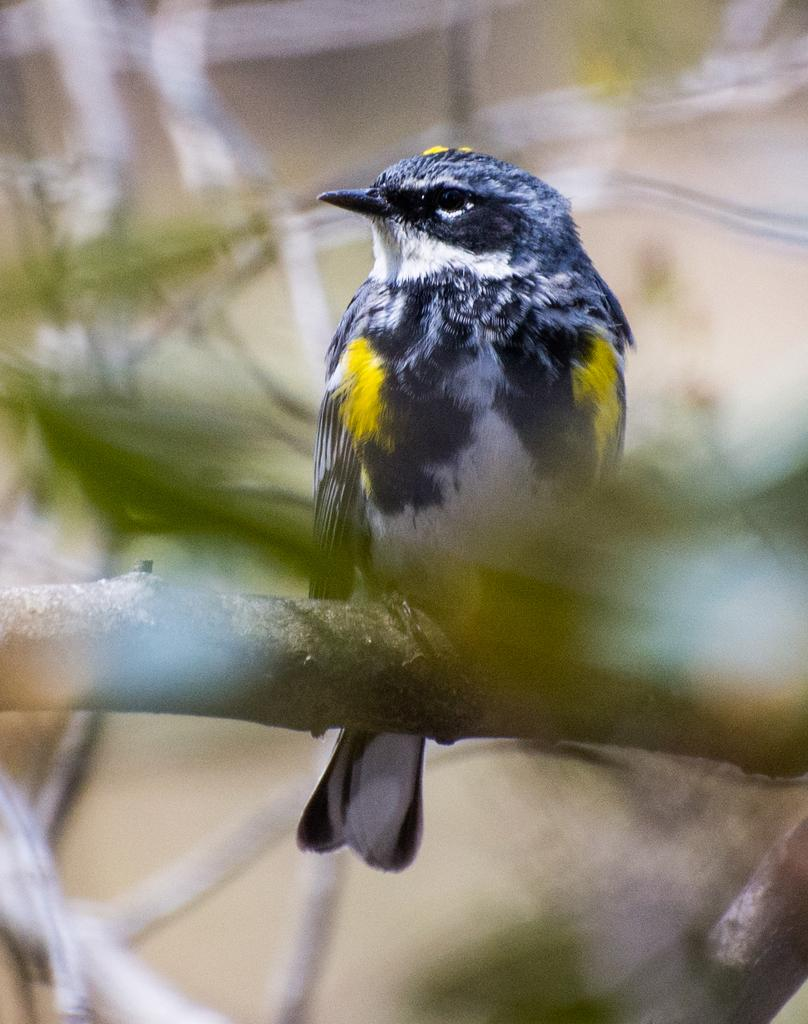What type of animal is in the image? There is a bird in the image. What colors can be seen on the bird? The bird has black and yellow coloring. Where is the bird located in the image? The bird is standing on a branch of a tree. What type of furniture can be seen in the image? There is no furniture present in the image; it features a bird on a tree branch. What answer does the bird provide in the image? The bird does not provide an answer in the image, as it is a photograph and not a conversation. 